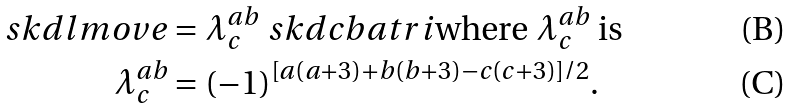Convert formula to latex. <formula><loc_0><loc_0><loc_500><loc_500>\ s k d { l m o v e } & = \lambda ^ { a b } _ { c } \ s k d { c b a t r i } \text {where $\lambda^{ab}_{c}$ is} \\ \lambda ^ { a b } _ { c } & = ( - 1 ) ^ { [ a ( a + 3 ) + b ( b + 3 ) - c ( c + 3 ) ] / 2 } .</formula> 